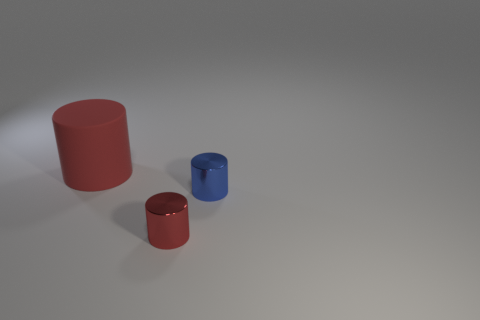Is the number of shiny cylinders that are in front of the red shiny object the same as the number of big rubber things right of the large rubber thing?
Your answer should be very brief. Yes. There is a small metallic thing to the left of the blue thing; does it have the same shape as the tiny blue shiny object?
Your response must be concise. Yes. The red thing in front of the tiny thing right of the red cylinder that is in front of the large matte object is what shape?
Ensure brevity in your answer.  Cylinder. There is a thing that is both to the left of the small blue cylinder and on the right side of the big cylinder; what is it made of?
Offer a very short reply. Metal. Are there fewer blue objects than tiny blue metal balls?
Your answer should be very brief. No. There is a tiny blue object; does it have the same shape as the small metal object that is in front of the small blue thing?
Provide a short and direct response. Yes. Is the size of the red thing that is on the right side of the red rubber object the same as the tiny blue object?
Keep it short and to the point. Yes. What shape is the other metallic thing that is the same size as the blue metallic thing?
Give a very brief answer. Cylinder. Does the red matte thing have the same shape as the small blue metallic object?
Your answer should be very brief. Yes. How many tiny metallic things have the same shape as the large object?
Offer a very short reply. 2. 